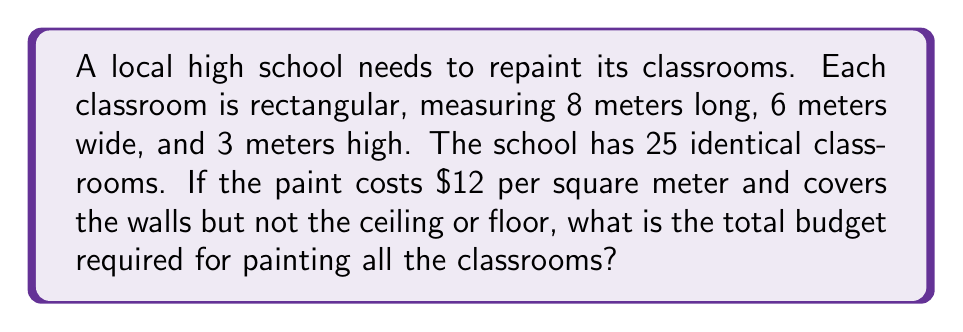Solve this math problem. 1. Calculate the surface area of one classroom's walls:
   - Two long walls: $2 \times (8\text{ m} \times 3\text{ m}) = 48\text{ m}^2$
   - Two short walls: $2 \times (6\text{ m} \times 3\text{ m}) = 36\text{ m}^2$
   - Total surface area per classroom: $48\text{ m}^2 + 36\text{ m}^2 = 84\text{ m}^2$

2. Calculate the total surface area for all 25 classrooms:
   $84\text{ m}^2 \times 25 = 2100\text{ m}^2$

3. Calculate the cost of painting:
   $2100\text{ m}^2 \times \$12/\text{m}^2 = \$25,200$

Therefore, the total budget required for painting all 25 classrooms is $\$25,200$.
Answer: $\$25,200$ 